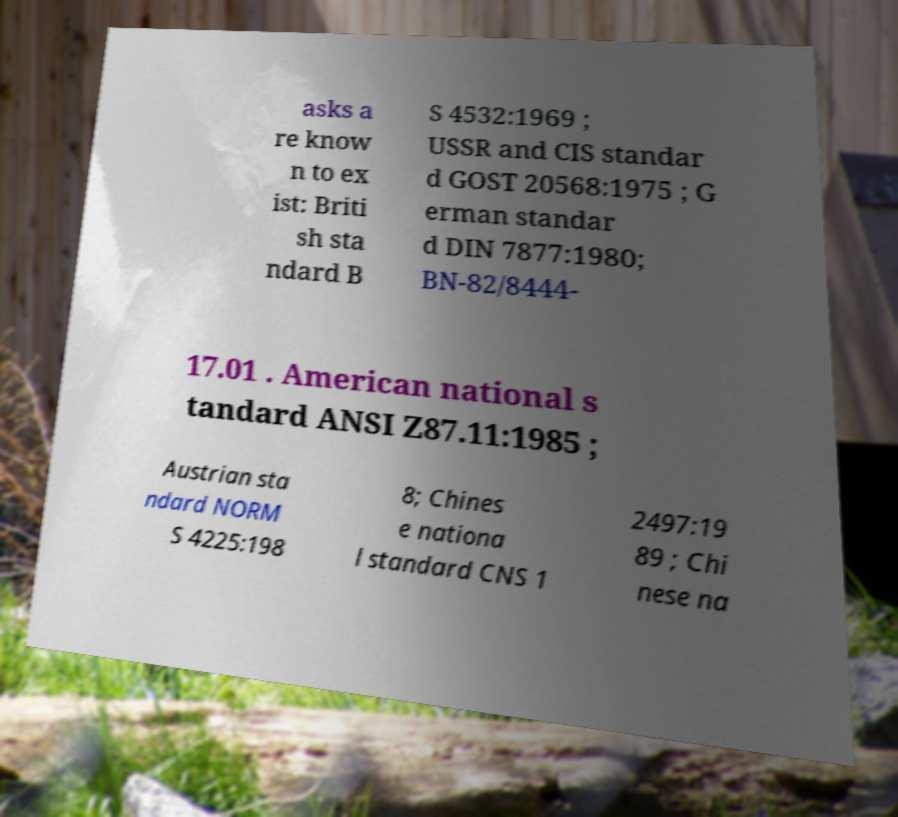There's text embedded in this image that I need extracted. Can you transcribe it verbatim? asks a re know n to ex ist: Briti sh sta ndard B S 4532:1969 ; USSR and CIS standar d GOST 20568:1975 ; G erman standar d DIN 7877:1980; BN-82/8444- 17.01 . American national s tandard ANSI Z87.11:1985 ; Austrian sta ndard NORM S 4225:198 8; Chines e nationa l standard CNS 1 2497:19 89 ; Chi nese na 